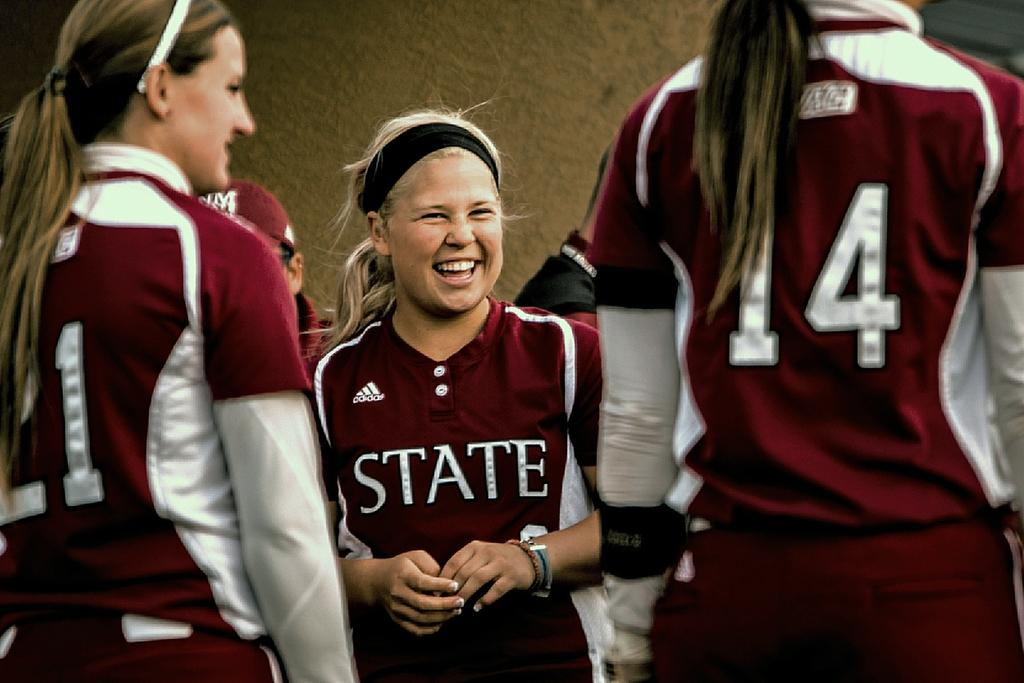Provide a one-sentence caption for the provided image. A group of cheerleaders are smiling and wearing matching burgundy uniforms that say State. 